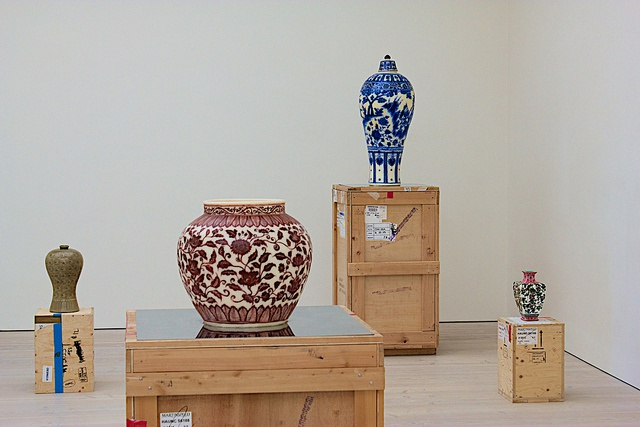Describe the objects in this image and their specific colors. I can see vase in lightgray, maroon, black, brown, and darkgray tones, vase in lightgray, navy, black, darkgray, and beige tones, vase in lightgray, olive, and gray tones, and vase in lightgray, black, darkgray, and gray tones in this image. 